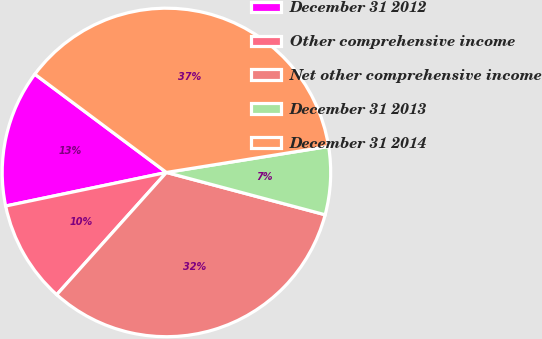<chart> <loc_0><loc_0><loc_500><loc_500><pie_chart><fcel>December 31 2012<fcel>Other comprehensive income<fcel>Net other comprehensive income<fcel>December 31 2013<fcel>December 31 2014<nl><fcel>13.48%<fcel>10.08%<fcel>32.5%<fcel>6.68%<fcel>37.27%<nl></chart> 